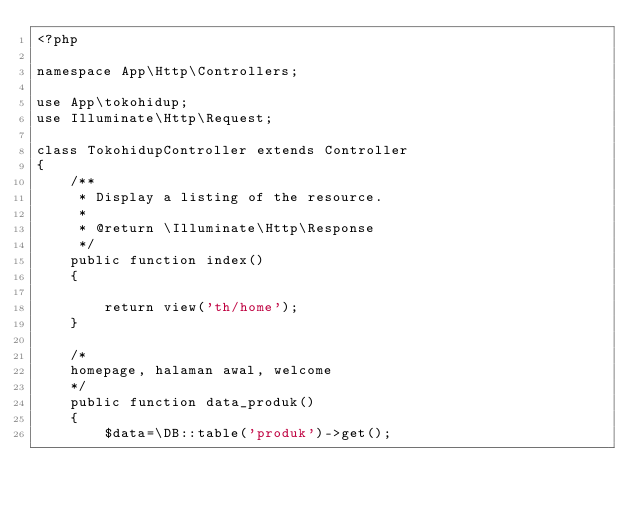<code> <loc_0><loc_0><loc_500><loc_500><_PHP_><?php

namespace App\Http\Controllers;

use App\tokohidup;
use Illuminate\Http\Request;

class TokohidupController extends Controller
{
    /**
     * Display a listing of the resource.
     *
     * @return \Illuminate\Http\Response
     */
    public function index()
    {
       
        return view('th/home');
    }

    /*
    homepage, halaman awal, welcome
    */
    public function data_produk()
    {
        $data=\DB::table('produk')->get();</code> 